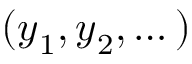Convert formula to latex. <formula><loc_0><loc_0><loc_500><loc_500>( { y } _ { 1 } , { y } _ { 2 } , \dots )</formula> 